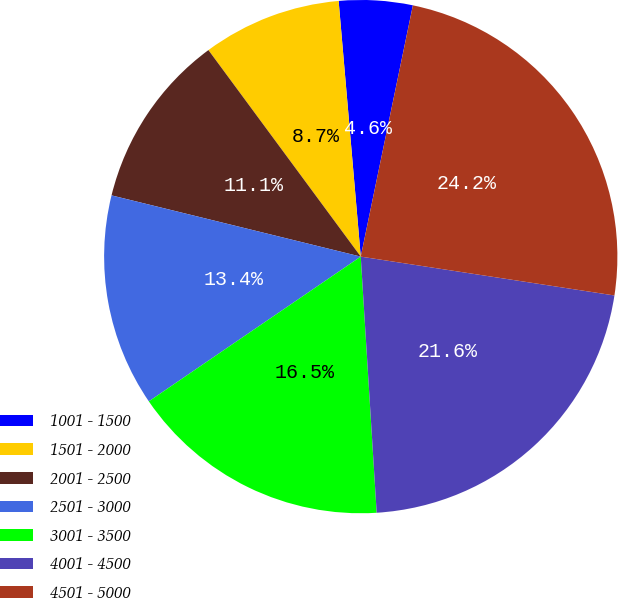<chart> <loc_0><loc_0><loc_500><loc_500><pie_chart><fcel>1001 - 1500<fcel>1501 - 2000<fcel>2001 - 2500<fcel>2501 - 3000<fcel>3001 - 3500<fcel>4001 - 4500<fcel>4501 - 5000<nl><fcel>4.63%<fcel>8.74%<fcel>11.05%<fcel>13.37%<fcel>16.45%<fcel>21.59%<fcel>24.16%<nl></chart> 